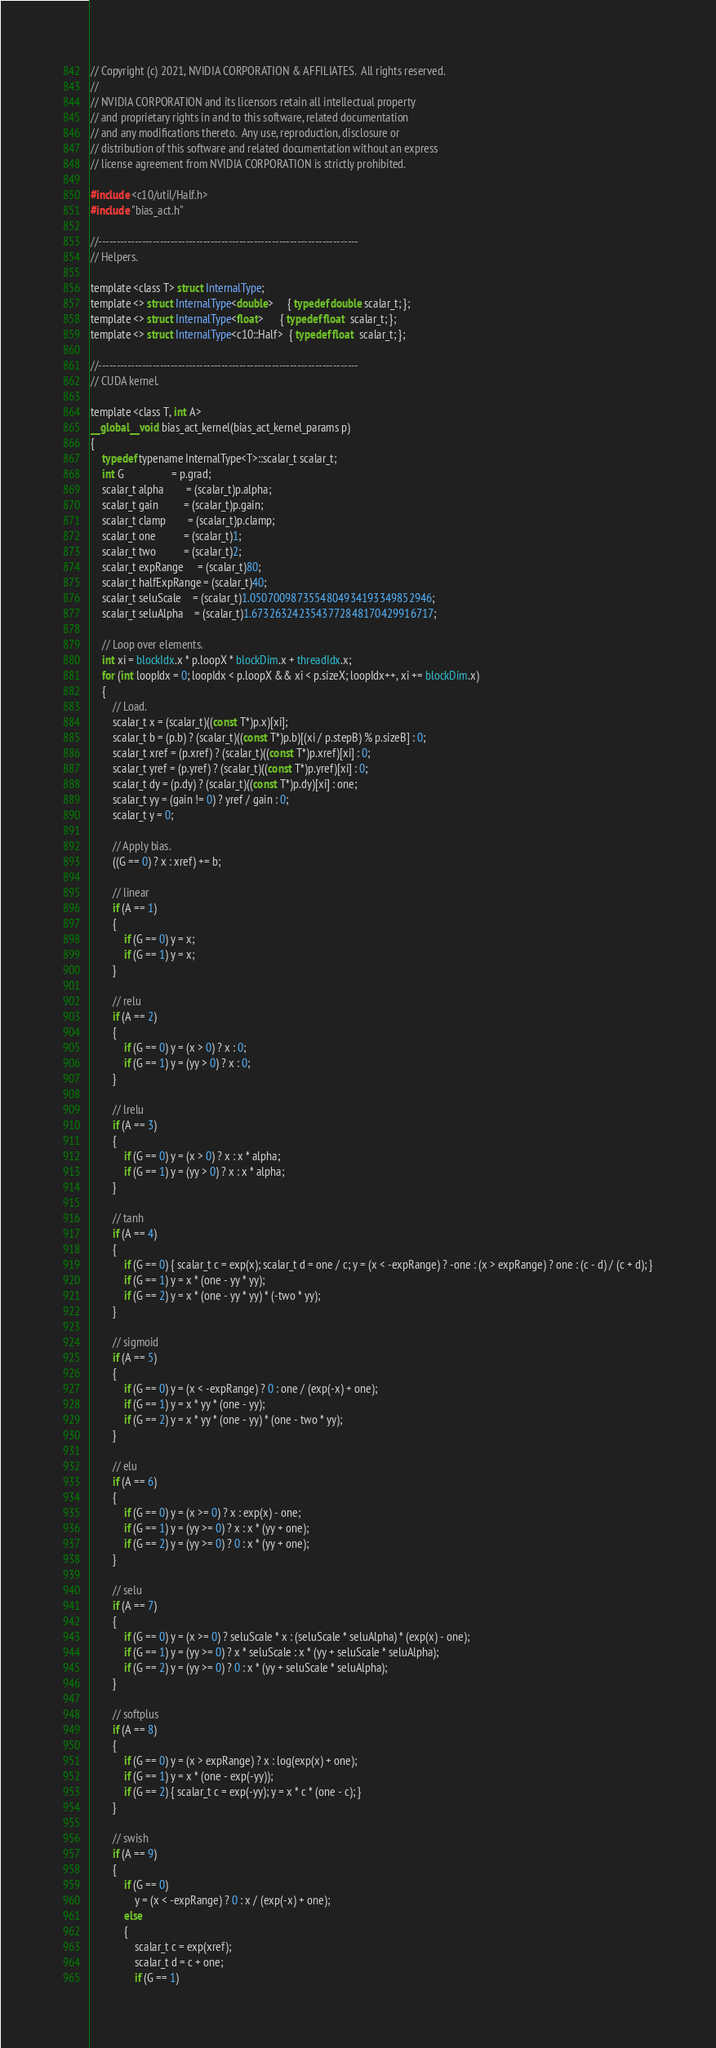Convert code to text. <code><loc_0><loc_0><loc_500><loc_500><_Cuda_>// Copyright (c) 2021, NVIDIA CORPORATION & AFFILIATES.  All rights reserved.
//
// NVIDIA CORPORATION and its licensors retain all intellectual property
// and proprietary rights in and to this software, related documentation
// and any modifications thereto.  Any use, reproduction, disclosure or
// distribution of this software and related documentation without an express
// license agreement from NVIDIA CORPORATION is strictly prohibited.

#include <c10/util/Half.h>
#include "bias_act.h"

//------------------------------------------------------------------------
// Helpers.

template <class T> struct InternalType;
template <> struct InternalType<double>     { typedef double scalar_t; };
template <> struct InternalType<float>      { typedef float  scalar_t; };
template <> struct InternalType<c10::Half>  { typedef float  scalar_t; };

//------------------------------------------------------------------------
// CUDA kernel.

template <class T, int A>
__global__ void bias_act_kernel(bias_act_kernel_params p)
{
    typedef typename InternalType<T>::scalar_t scalar_t;
    int G                 = p.grad;
    scalar_t alpha        = (scalar_t)p.alpha;
    scalar_t gain         = (scalar_t)p.gain;
    scalar_t clamp        = (scalar_t)p.clamp;
    scalar_t one          = (scalar_t)1;
    scalar_t two          = (scalar_t)2;
    scalar_t expRange     = (scalar_t)80;
    scalar_t halfExpRange = (scalar_t)40;
    scalar_t seluScale    = (scalar_t)1.0507009873554804934193349852946;
    scalar_t seluAlpha    = (scalar_t)1.6732632423543772848170429916717;

    // Loop over elements.
    int xi = blockIdx.x * p.loopX * blockDim.x + threadIdx.x;
    for (int loopIdx = 0; loopIdx < p.loopX && xi < p.sizeX; loopIdx++, xi += blockDim.x)
    {
        // Load.
        scalar_t x = (scalar_t)((const T*)p.x)[xi];
        scalar_t b = (p.b) ? (scalar_t)((const T*)p.b)[(xi / p.stepB) % p.sizeB] : 0;
        scalar_t xref = (p.xref) ? (scalar_t)((const T*)p.xref)[xi] : 0;
        scalar_t yref = (p.yref) ? (scalar_t)((const T*)p.yref)[xi] : 0;
        scalar_t dy = (p.dy) ? (scalar_t)((const T*)p.dy)[xi] : one;
        scalar_t yy = (gain != 0) ? yref / gain : 0;
        scalar_t y = 0;

        // Apply bias.
        ((G == 0) ? x : xref) += b;

        // linear
        if (A == 1)
        {
            if (G == 0) y = x;
            if (G == 1) y = x;
        }

        // relu
        if (A == 2)
        {
            if (G == 0) y = (x > 0) ? x : 0;
            if (G == 1) y = (yy > 0) ? x : 0;
        }

        // lrelu
        if (A == 3)
        {
            if (G == 0) y = (x > 0) ? x : x * alpha;
            if (G == 1) y = (yy > 0) ? x : x * alpha;
        }

        // tanh
        if (A == 4)
        {
            if (G == 0) { scalar_t c = exp(x); scalar_t d = one / c; y = (x < -expRange) ? -one : (x > expRange) ? one : (c - d) / (c + d); }
            if (G == 1) y = x * (one - yy * yy);
            if (G == 2) y = x * (one - yy * yy) * (-two * yy);
        }

        // sigmoid
        if (A == 5)
        {
            if (G == 0) y = (x < -expRange) ? 0 : one / (exp(-x) + one);
            if (G == 1) y = x * yy * (one - yy);
            if (G == 2) y = x * yy * (one - yy) * (one - two * yy);
        }

        // elu
        if (A == 6)
        {
            if (G == 0) y = (x >= 0) ? x : exp(x) - one;
            if (G == 1) y = (yy >= 0) ? x : x * (yy + one);
            if (G == 2) y = (yy >= 0) ? 0 : x * (yy + one);
        }

        // selu
        if (A == 7)
        {
            if (G == 0) y = (x >= 0) ? seluScale * x : (seluScale * seluAlpha) * (exp(x) - one);
            if (G == 1) y = (yy >= 0) ? x * seluScale : x * (yy + seluScale * seluAlpha);
            if (G == 2) y = (yy >= 0) ? 0 : x * (yy + seluScale * seluAlpha);
        }

        // softplus
        if (A == 8)
        {
            if (G == 0) y = (x > expRange) ? x : log(exp(x) + one);
            if (G == 1) y = x * (one - exp(-yy));
            if (G == 2) { scalar_t c = exp(-yy); y = x * c * (one - c); }
        }

        // swish
        if (A == 9)
        {
            if (G == 0)
                y = (x < -expRange) ? 0 : x / (exp(-x) + one);
            else
            {
                scalar_t c = exp(xref);
                scalar_t d = c + one;
                if (G == 1)</code> 